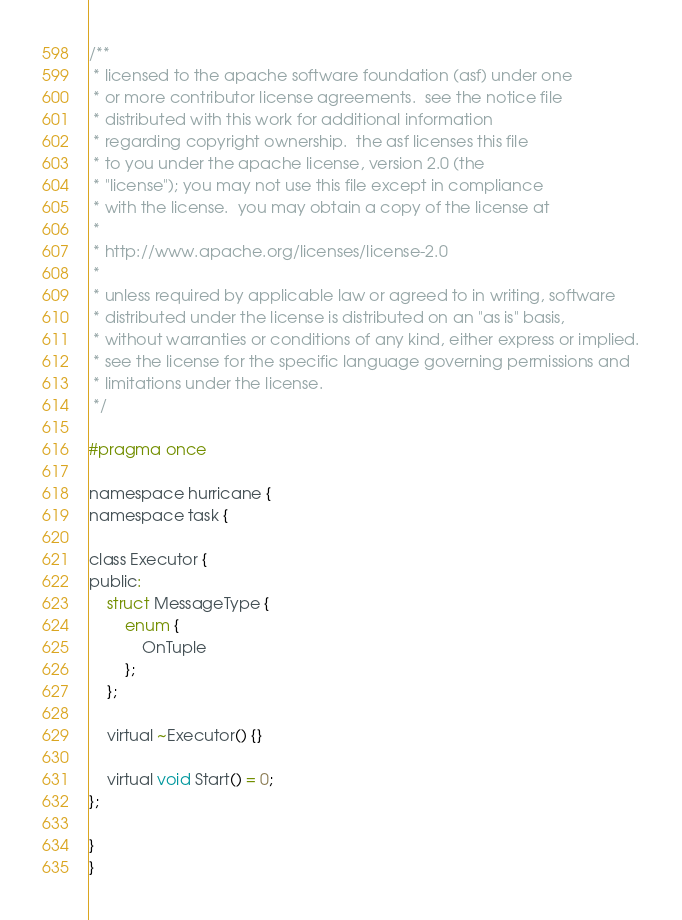<code> <loc_0><loc_0><loc_500><loc_500><_C_>/**
 * licensed to the apache software foundation (asf) under one
 * or more contributor license agreements.  see the notice file
 * distributed with this work for additional information
 * regarding copyright ownership.  the asf licenses this file
 * to you under the apache license, version 2.0 (the
 * "license"); you may not use this file except in compliance
 * with the license.  you may obtain a copy of the license at
 *
 * http://www.apache.org/licenses/license-2.0
 *
 * unless required by applicable law or agreed to in writing, software
 * distributed under the license is distributed on an "as is" basis,
 * without warranties or conditions of any kind, either express or implied.
 * see the license for the specific language governing permissions and
 * limitations under the license.
 */

#pragma once

namespace hurricane {
namespace task {

class Executor {
public:
    struct MessageType {
        enum {
            OnTuple
        };
    };

    virtual ~Executor() {}

    virtual void Start() = 0;
};

}
}
</code> 